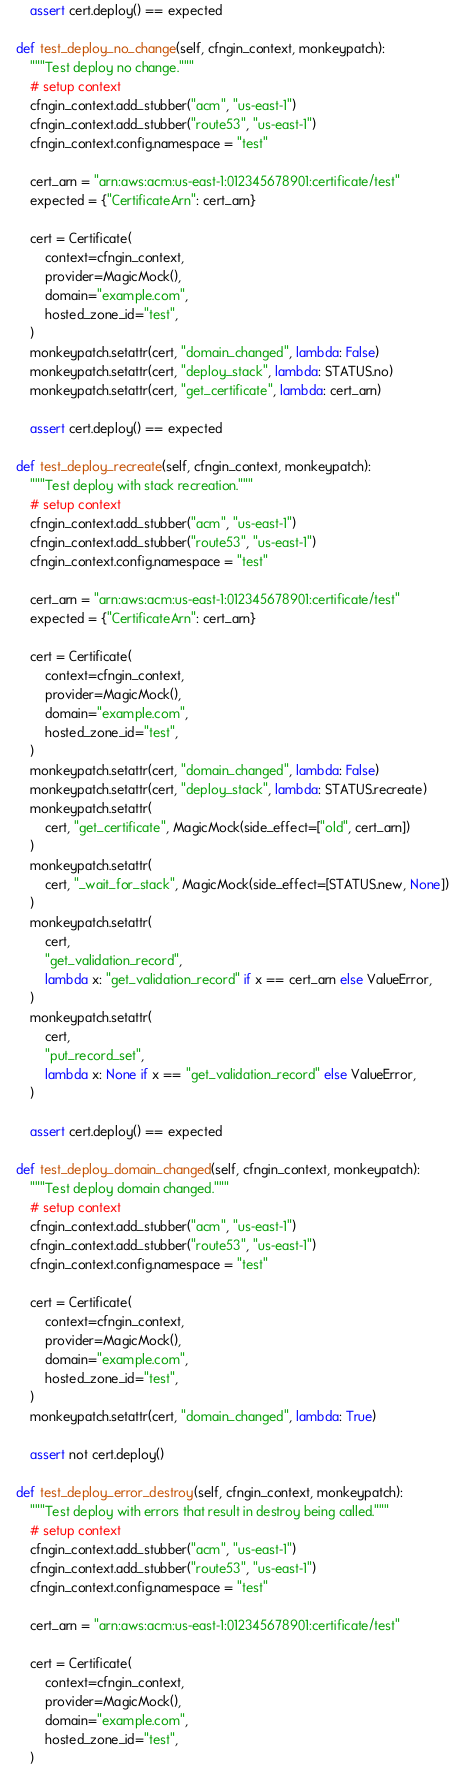<code> <loc_0><loc_0><loc_500><loc_500><_Python_>
        assert cert.deploy() == expected

    def test_deploy_no_change(self, cfngin_context, monkeypatch):
        """Test deploy no change."""
        # setup context
        cfngin_context.add_stubber("acm", "us-east-1")
        cfngin_context.add_stubber("route53", "us-east-1")
        cfngin_context.config.namespace = "test"

        cert_arn = "arn:aws:acm:us-east-1:012345678901:certificate/test"
        expected = {"CertificateArn": cert_arn}

        cert = Certificate(
            context=cfngin_context,
            provider=MagicMock(),
            domain="example.com",
            hosted_zone_id="test",
        )
        monkeypatch.setattr(cert, "domain_changed", lambda: False)
        monkeypatch.setattr(cert, "deploy_stack", lambda: STATUS.no)
        monkeypatch.setattr(cert, "get_certificate", lambda: cert_arn)

        assert cert.deploy() == expected

    def test_deploy_recreate(self, cfngin_context, monkeypatch):
        """Test deploy with stack recreation."""
        # setup context
        cfngin_context.add_stubber("acm", "us-east-1")
        cfngin_context.add_stubber("route53", "us-east-1")
        cfngin_context.config.namespace = "test"

        cert_arn = "arn:aws:acm:us-east-1:012345678901:certificate/test"
        expected = {"CertificateArn": cert_arn}

        cert = Certificate(
            context=cfngin_context,
            provider=MagicMock(),
            domain="example.com",
            hosted_zone_id="test",
        )
        monkeypatch.setattr(cert, "domain_changed", lambda: False)
        monkeypatch.setattr(cert, "deploy_stack", lambda: STATUS.recreate)
        monkeypatch.setattr(
            cert, "get_certificate", MagicMock(side_effect=["old", cert_arn])
        )
        monkeypatch.setattr(
            cert, "_wait_for_stack", MagicMock(side_effect=[STATUS.new, None])
        )
        monkeypatch.setattr(
            cert,
            "get_validation_record",
            lambda x: "get_validation_record" if x == cert_arn else ValueError,
        )
        monkeypatch.setattr(
            cert,
            "put_record_set",
            lambda x: None if x == "get_validation_record" else ValueError,
        )

        assert cert.deploy() == expected

    def test_deploy_domain_changed(self, cfngin_context, monkeypatch):
        """Test deploy domain changed."""
        # setup context
        cfngin_context.add_stubber("acm", "us-east-1")
        cfngin_context.add_stubber("route53", "us-east-1")
        cfngin_context.config.namespace = "test"

        cert = Certificate(
            context=cfngin_context,
            provider=MagicMock(),
            domain="example.com",
            hosted_zone_id="test",
        )
        monkeypatch.setattr(cert, "domain_changed", lambda: True)

        assert not cert.deploy()

    def test_deploy_error_destroy(self, cfngin_context, monkeypatch):
        """Test deploy with errors that result in destroy being called."""
        # setup context
        cfngin_context.add_stubber("acm", "us-east-1")
        cfngin_context.add_stubber("route53", "us-east-1")
        cfngin_context.config.namespace = "test"

        cert_arn = "arn:aws:acm:us-east-1:012345678901:certificate/test"

        cert = Certificate(
            context=cfngin_context,
            provider=MagicMock(),
            domain="example.com",
            hosted_zone_id="test",
        )
</code> 